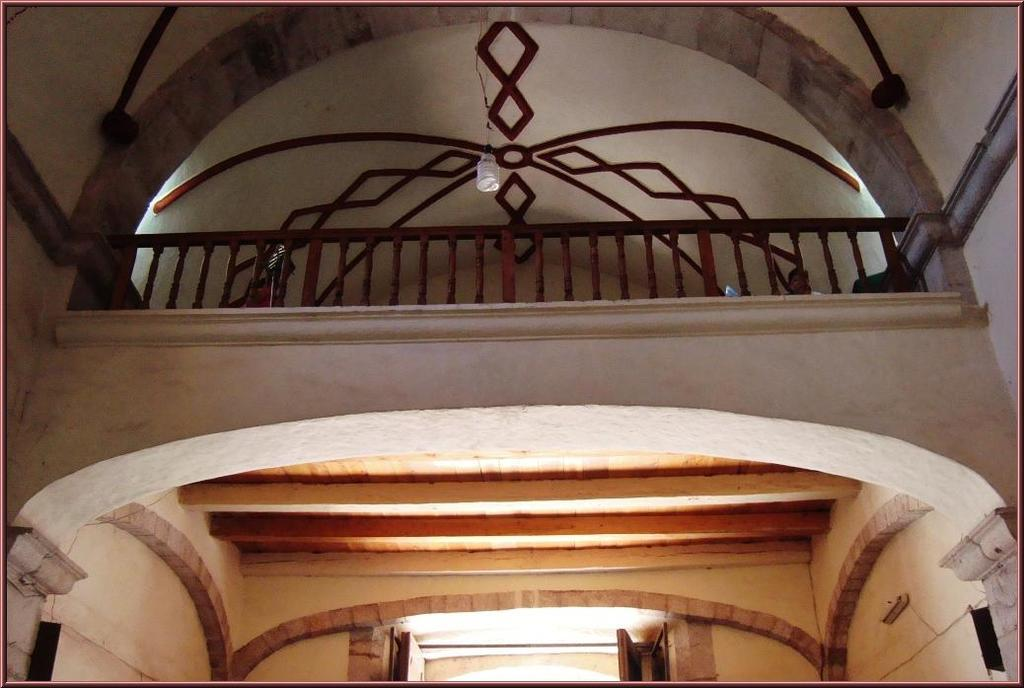What type of location is depicted in the image? The image is of the inside of a building. What kind of barrier can be seen in the image? There is a wooden fence in the image. Is there any source of illumination attached to the wooden fence? Yes, there is a light on top of the wooden fence. What architectural feature is visible in the building? There are arches visible in the building. What type of stamp does your uncle collect, and is it visible in the image? There is no mention of an uncle or a stamp in the image, so we cannot answer that question. 